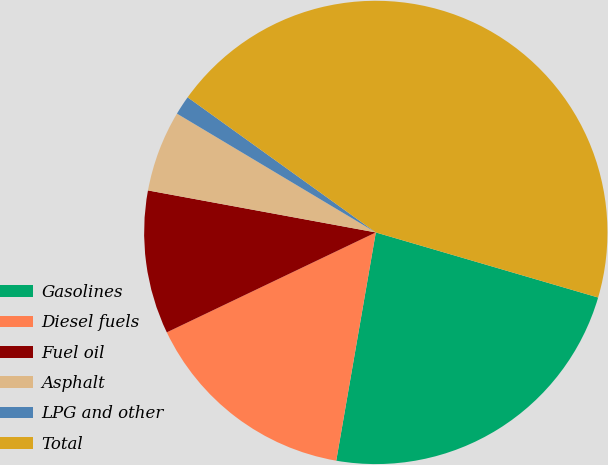Convert chart. <chart><loc_0><loc_0><loc_500><loc_500><pie_chart><fcel>Gasolines<fcel>Diesel fuels<fcel>Fuel oil<fcel>Asphalt<fcel>LPG and other<fcel>Total<nl><fcel>23.2%<fcel>15.17%<fcel>10.0%<fcel>5.67%<fcel>1.34%<fcel>44.62%<nl></chart> 